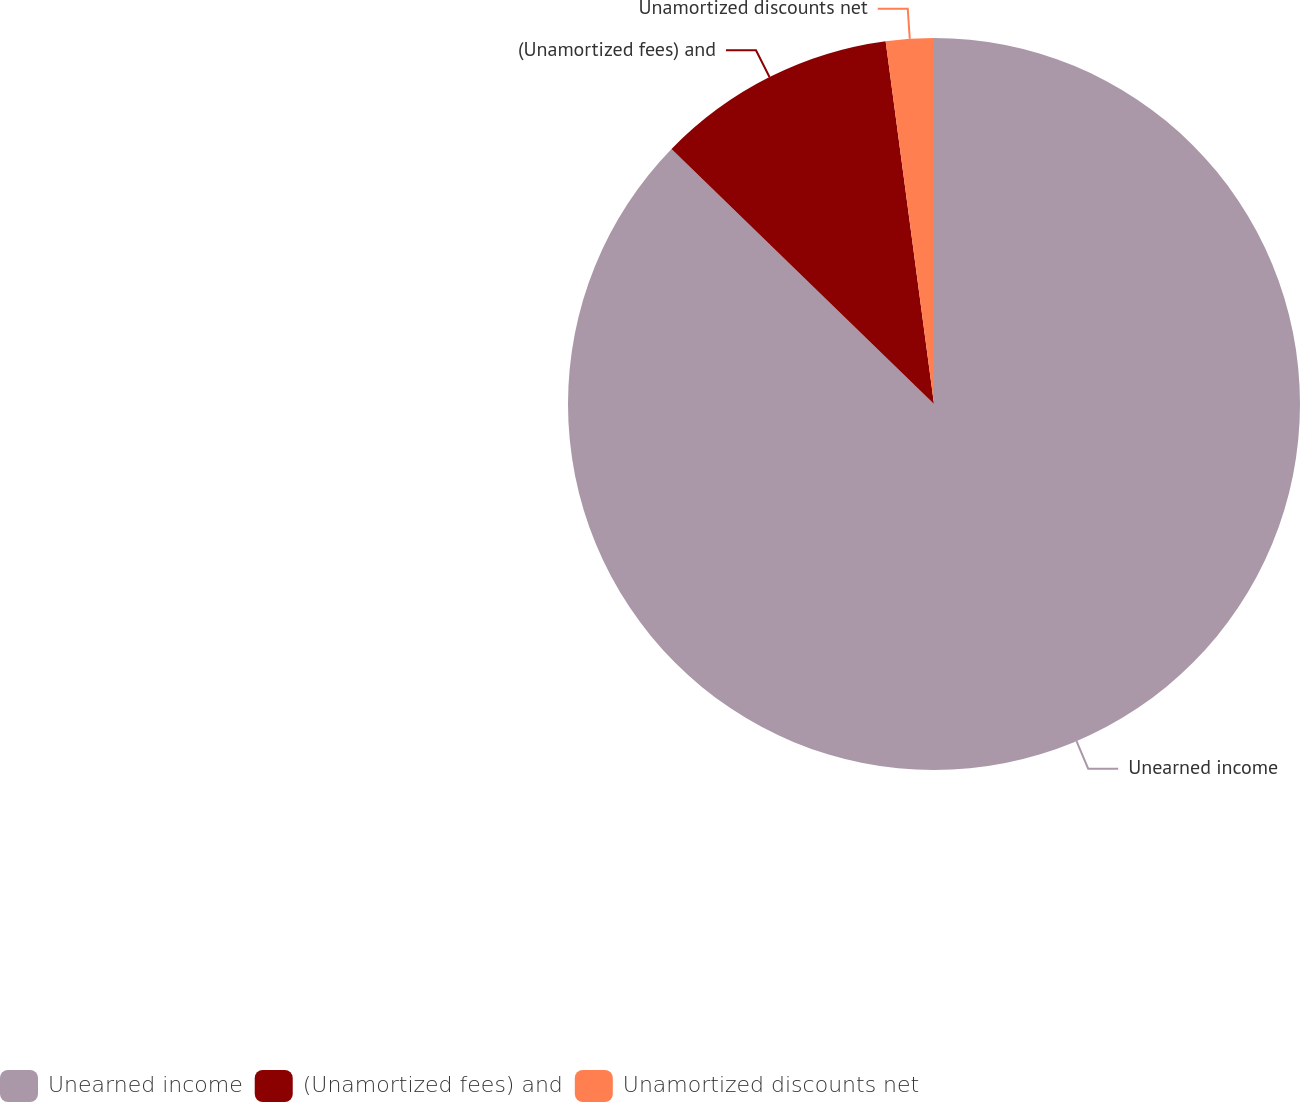<chart> <loc_0><loc_0><loc_500><loc_500><pie_chart><fcel>Unearned income<fcel>(Unamortized fees) and<fcel>Unamortized discounts net<nl><fcel>87.27%<fcel>10.62%<fcel>2.11%<nl></chart> 